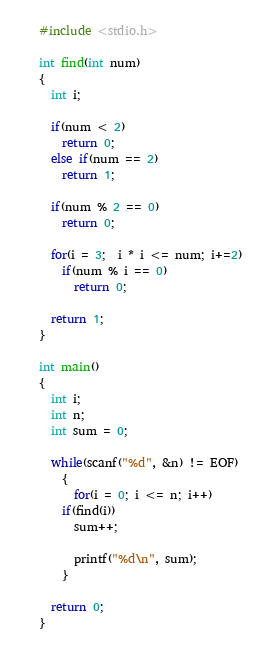<code> <loc_0><loc_0><loc_500><loc_500><_C_>#include <stdio.h>

int find(int num)
{
  int i;

  if(num < 2)
    return 0;
  else if(num == 2)
    return 1;

  if(num % 2 == 0)
    return 0;

  for(i = 3;  i * i <= num; i+=2)
    if(num % i == 0)
      return 0;

  return 1;
}

int main()
{
  int i;
  int n;
  int sum = 0;

  while(scanf("%d", &n) != EOF)
    {
      for(i = 0; i <= n; i++)
	if(find(i))
	  sum++;

      printf("%d\n", sum);
    }

  return 0;
}</code> 